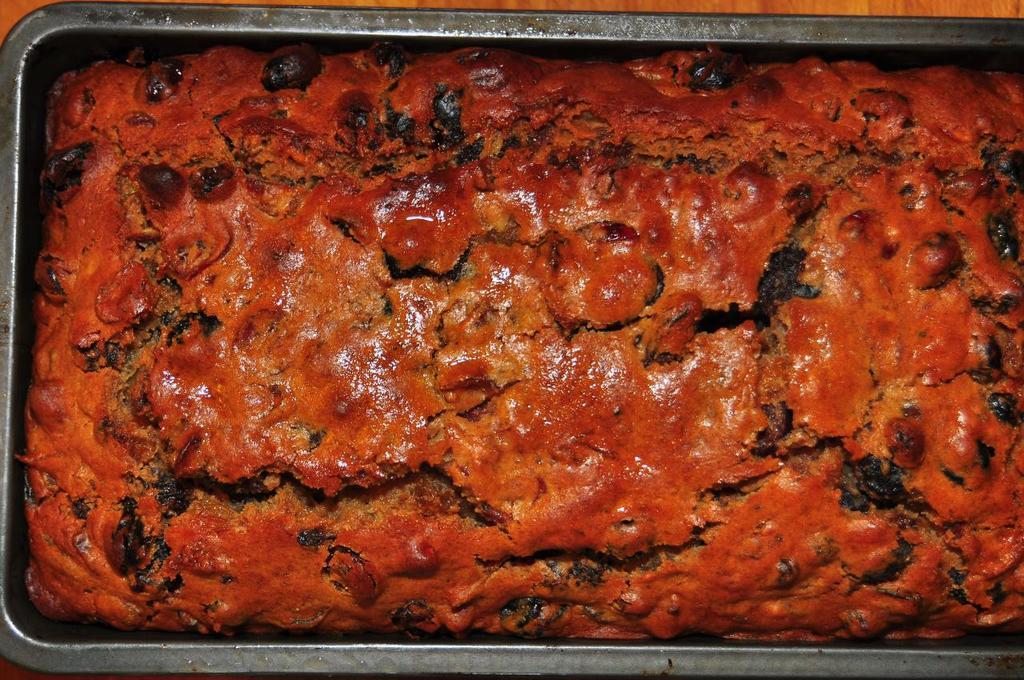Please provide a concise description of this image. In this picture I can observe some food. This food is in red color. The food is placed in the box. This box is placed on the brown color table. 